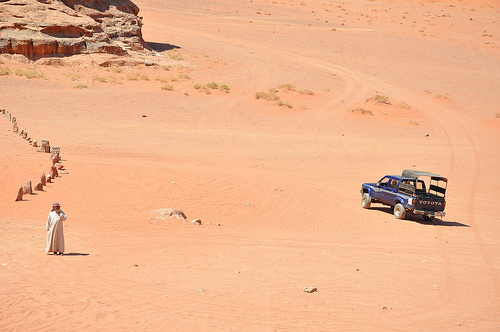<image>
Can you confirm if the rock is on the man? No. The rock is not positioned on the man. They may be near each other, but the rock is not supported by or resting on top of the man. Where is the man in relation to the jeep? Is it behind the jeep? No. The man is not behind the jeep. From this viewpoint, the man appears to be positioned elsewhere in the scene. 